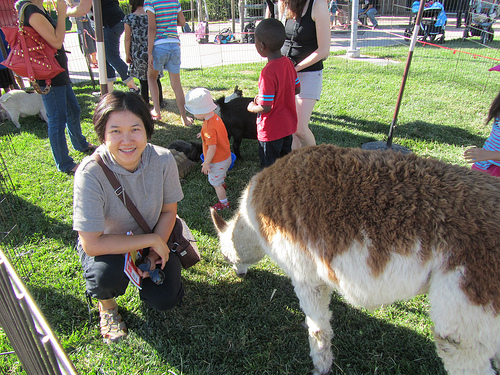Please provide the bounding box coordinate of the region this sentence describes: young boy wearing red shirt and black pants. The bounding box coordinates for the young boy wearing a red shirt and black pants are [0.48, 0.16, 0.61, 0.46]. 